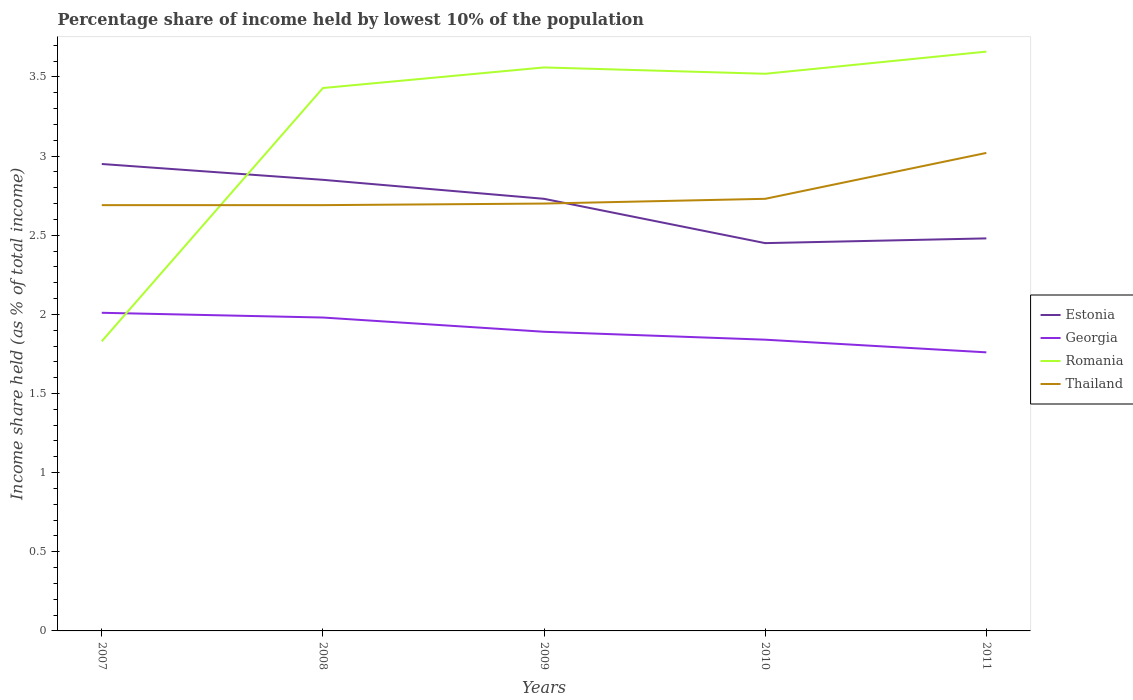Is the number of lines equal to the number of legend labels?
Provide a short and direct response. Yes. Across all years, what is the maximum percentage share of income held by lowest 10% of the population in Georgia?
Your answer should be compact. 1.76. What is the total percentage share of income held by lowest 10% of the population in Romania in the graph?
Offer a terse response. -0.1. What is the difference between the highest and the second highest percentage share of income held by lowest 10% of the population in Estonia?
Provide a short and direct response. 0.5. Is the percentage share of income held by lowest 10% of the population in Romania strictly greater than the percentage share of income held by lowest 10% of the population in Thailand over the years?
Give a very brief answer. No. How many years are there in the graph?
Provide a succinct answer. 5. What is the difference between two consecutive major ticks on the Y-axis?
Offer a very short reply. 0.5. Are the values on the major ticks of Y-axis written in scientific E-notation?
Offer a very short reply. No. Does the graph contain any zero values?
Offer a terse response. No. Does the graph contain grids?
Provide a succinct answer. No. Where does the legend appear in the graph?
Ensure brevity in your answer.  Center right. What is the title of the graph?
Keep it short and to the point. Percentage share of income held by lowest 10% of the population. What is the label or title of the Y-axis?
Provide a succinct answer. Income share held (as % of total income). What is the Income share held (as % of total income) of Estonia in 2007?
Offer a terse response. 2.95. What is the Income share held (as % of total income) in Georgia in 2007?
Keep it short and to the point. 2.01. What is the Income share held (as % of total income) of Romania in 2007?
Your answer should be compact. 1.83. What is the Income share held (as % of total income) of Thailand in 2007?
Offer a very short reply. 2.69. What is the Income share held (as % of total income) of Estonia in 2008?
Provide a short and direct response. 2.85. What is the Income share held (as % of total income) of Georgia in 2008?
Offer a very short reply. 1.98. What is the Income share held (as % of total income) in Romania in 2008?
Keep it short and to the point. 3.43. What is the Income share held (as % of total income) of Thailand in 2008?
Make the answer very short. 2.69. What is the Income share held (as % of total income) in Estonia in 2009?
Offer a very short reply. 2.73. What is the Income share held (as % of total income) in Georgia in 2009?
Ensure brevity in your answer.  1.89. What is the Income share held (as % of total income) of Romania in 2009?
Keep it short and to the point. 3.56. What is the Income share held (as % of total income) in Estonia in 2010?
Provide a short and direct response. 2.45. What is the Income share held (as % of total income) in Georgia in 2010?
Your answer should be compact. 1.84. What is the Income share held (as % of total income) of Romania in 2010?
Keep it short and to the point. 3.52. What is the Income share held (as % of total income) of Thailand in 2010?
Make the answer very short. 2.73. What is the Income share held (as % of total income) in Estonia in 2011?
Keep it short and to the point. 2.48. What is the Income share held (as % of total income) of Georgia in 2011?
Offer a terse response. 1.76. What is the Income share held (as % of total income) in Romania in 2011?
Provide a succinct answer. 3.66. What is the Income share held (as % of total income) in Thailand in 2011?
Provide a short and direct response. 3.02. Across all years, what is the maximum Income share held (as % of total income) in Estonia?
Your answer should be very brief. 2.95. Across all years, what is the maximum Income share held (as % of total income) of Georgia?
Ensure brevity in your answer.  2.01. Across all years, what is the maximum Income share held (as % of total income) in Romania?
Keep it short and to the point. 3.66. Across all years, what is the maximum Income share held (as % of total income) of Thailand?
Make the answer very short. 3.02. Across all years, what is the minimum Income share held (as % of total income) of Estonia?
Provide a succinct answer. 2.45. Across all years, what is the minimum Income share held (as % of total income) of Georgia?
Provide a succinct answer. 1.76. Across all years, what is the minimum Income share held (as % of total income) in Romania?
Provide a succinct answer. 1.83. Across all years, what is the minimum Income share held (as % of total income) of Thailand?
Ensure brevity in your answer.  2.69. What is the total Income share held (as % of total income) in Estonia in the graph?
Provide a short and direct response. 13.46. What is the total Income share held (as % of total income) of Georgia in the graph?
Provide a short and direct response. 9.48. What is the total Income share held (as % of total income) of Romania in the graph?
Give a very brief answer. 16. What is the total Income share held (as % of total income) in Thailand in the graph?
Ensure brevity in your answer.  13.83. What is the difference between the Income share held (as % of total income) of Estonia in 2007 and that in 2008?
Provide a short and direct response. 0.1. What is the difference between the Income share held (as % of total income) in Romania in 2007 and that in 2008?
Provide a succinct answer. -1.6. What is the difference between the Income share held (as % of total income) in Thailand in 2007 and that in 2008?
Offer a very short reply. 0. What is the difference between the Income share held (as % of total income) of Estonia in 2007 and that in 2009?
Give a very brief answer. 0.22. What is the difference between the Income share held (as % of total income) of Georgia in 2007 and that in 2009?
Ensure brevity in your answer.  0.12. What is the difference between the Income share held (as % of total income) in Romania in 2007 and that in 2009?
Offer a very short reply. -1.73. What is the difference between the Income share held (as % of total income) in Thailand in 2007 and that in 2009?
Keep it short and to the point. -0.01. What is the difference between the Income share held (as % of total income) of Estonia in 2007 and that in 2010?
Provide a short and direct response. 0.5. What is the difference between the Income share held (as % of total income) of Georgia in 2007 and that in 2010?
Keep it short and to the point. 0.17. What is the difference between the Income share held (as % of total income) of Romania in 2007 and that in 2010?
Your answer should be compact. -1.69. What is the difference between the Income share held (as % of total income) of Thailand in 2007 and that in 2010?
Provide a succinct answer. -0.04. What is the difference between the Income share held (as % of total income) of Estonia in 2007 and that in 2011?
Provide a succinct answer. 0.47. What is the difference between the Income share held (as % of total income) in Romania in 2007 and that in 2011?
Your answer should be compact. -1.83. What is the difference between the Income share held (as % of total income) in Thailand in 2007 and that in 2011?
Your response must be concise. -0.33. What is the difference between the Income share held (as % of total income) in Estonia in 2008 and that in 2009?
Your answer should be compact. 0.12. What is the difference between the Income share held (as % of total income) of Georgia in 2008 and that in 2009?
Your response must be concise. 0.09. What is the difference between the Income share held (as % of total income) in Romania in 2008 and that in 2009?
Offer a terse response. -0.13. What is the difference between the Income share held (as % of total income) of Thailand in 2008 and that in 2009?
Provide a short and direct response. -0.01. What is the difference between the Income share held (as % of total income) in Georgia in 2008 and that in 2010?
Your answer should be compact. 0.14. What is the difference between the Income share held (as % of total income) in Romania in 2008 and that in 2010?
Give a very brief answer. -0.09. What is the difference between the Income share held (as % of total income) in Thailand in 2008 and that in 2010?
Ensure brevity in your answer.  -0.04. What is the difference between the Income share held (as % of total income) of Estonia in 2008 and that in 2011?
Offer a terse response. 0.37. What is the difference between the Income share held (as % of total income) in Georgia in 2008 and that in 2011?
Offer a very short reply. 0.22. What is the difference between the Income share held (as % of total income) of Romania in 2008 and that in 2011?
Provide a succinct answer. -0.23. What is the difference between the Income share held (as % of total income) of Thailand in 2008 and that in 2011?
Give a very brief answer. -0.33. What is the difference between the Income share held (as % of total income) in Estonia in 2009 and that in 2010?
Provide a succinct answer. 0.28. What is the difference between the Income share held (as % of total income) in Romania in 2009 and that in 2010?
Ensure brevity in your answer.  0.04. What is the difference between the Income share held (as % of total income) in Thailand in 2009 and that in 2010?
Your answer should be very brief. -0.03. What is the difference between the Income share held (as % of total income) of Estonia in 2009 and that in 2011?
Offer a very short reply. 0.25. What is the difference between the Income share held (as % of total income) in Georgia in 2009 and that in 2011?
Ensure brevity in your answer.  0.13. What is the difference between the Income share held (as % of total income) in Romania in 2009 and that in 2011?
Provide a succinct answer. -0.1. What is the difference between the Income share held (as % of total income) in Thailand in 2009 and that in 2011?
Provide a succinct answer. -0.32. What is the difference between the Income share held (as % of total income) of Estonia in 2010 and that in 2011?
Provide a short and direct response. -0.03. What is the difference between the Income share held (as % of total income) in Romania in 2010 and that in 2011?
Ensure brevity in your answer.  -0.14. What is the difference between the Income share held (as % of total income) of Thailand in 2010 and that in 2011?
Offer a terse response. -0.29. What is the difference between the Income share held (as % of total income) of Estonia in 2007 and the Income share held (as % of total income) of Romania in 2008?
Make the answer very short. -0.48. What is the difference between the Income share held (as % of total income) of Estonia in 2007 and the Income share held (as % of total income) of Thailand in 2008?
Provide a succinct answer. 0.26. What is the difference between the Income share held (as % of total income) in Georgia in 2007 and the Income share held (as % of total income) in Romania in 2008?
Provide a succinct answer. -1.42. What is the difference between the Income share held (as % of total income) of Georgia in 2007 and the Income share held (as % of total income) of Thailand in 2008?
Give a very brief answer. -0.68. What is the difference between the Income share held (as % of total income) of Romania in 2007 and the Income share held (as % of total income) of Thailand in 2008?
Offer a very short reply. -0.86. What is the difference between the Income share held (as % of total income) in Estonia in 2007 and the Income share held (as % of total income) in Georgia in 2009?
Offer a very short reply. 1.06. What is the difference between the Income share held (as % of total income) in Estonia in 2007 and the Income share held (as % of total income) in Romania in 2009?
Keep it short and to the point. -0.61. What is the difference between the Income share held (as % of total income) in Georgia in 2007 and the Income share held (as % of total income) in Romania in 2009?
Your response must be concise. -1.55. What is the difference between the Income share held (as % of total income) of Georgia in 2007 and the Income share held (as % of total income) of Thailand in 2009?
Provide a succinct answer. -0.69. What is the difference between the Income share held (as % of total income) of Romania in 2007 and the Income share held (as % of total income) of Thailand in 2009?
Keep it short and to the point. -0.87. What is the difference between the Income share held (as % of total income) of Estonia in 2007 and the Income share held (as % of total income) of Georgia in 2010?
Your answer should be very brief. 1.11. What is the difference between the Income share held (as % of total income) in Estonia in 2007 and the Income share held (as % of total income) in Romania in 2010?
Your answer should be very brief. -0.57. What is the difference between the Income share held (as % of total income) in Estonia in 2007 and the Income share held (as % of total income) in Thailand in 2010?
Your response must be concise. 0.22. What is the difference between the Income share held (as % of total income) in Georgia in 2007 and the Income share held (as % of total income) in Romania in 2010?
Ensure brevity in your answer.  -1.51. What is the difference between the Income share held (as % of total income) of Georgia in 2007 and the Income share held (as % of total income) of Thailand in 2010?
Give a very brief answer. -0.72. What is the difference between the Income share held (as % of total income) in Romania in 2007 and the Income share held (as % of total income) in Thailand in 2010?
Your response must be concise. -0.9. What is the difference between the Income share held (as % of total income) in Estonia in 2007 and the Income share held (as % of total income) in Georgia in 2011?
Make the answer very short. 1.19. What is the difference between the Income share held (as % of total income) in Estonia in 2007 and the Income share held (as % of total income) in Romania in 2011?
Give a very brief answer. -0.71. What is the difference between the Income share held (as % of total income) in Estonia in 2007 and the Income share held (as % of total income) in Thailand in 2011?
Offer a very short reply. -0.07. What is the difference between the Income share held (as % of total income) in Georgia in 2007 and the Income share held (as % of total income) in Romania in 2011?
Make the answer very short. -1.65. What is the difference between the Income share held (as % of total income) of Georgia in 2007 and the Income share held (as % of total income) of Thailand in 2011?
Your answer should be compact. -1.01. What is the difference between the Income share held (as % of total income) in Romania in 2007 and the Income share held (as % of total income) in Thailand in 2011?
Make the answer very short. -1.19. What is the difference between the Income share held (as % of total income) of Estonia in 2008 and the Income share held (as % of total income) of Romania in 2009?
Your answer should be very brief. -0.71. What is the difference between the Income share held (as % of total income) of Georgia in 2008 and the Income share held (as % of total income) of Romania in 2009?
Provide a short and direct response. -1.58. What is the difference between the Income share held (as % of total income) of Georgia in 2008 and the Income share held (as % of total income) of Thailand in 2009?
Your response must be concise. -0.72. What is the difference between the Income share held (as % of total income) in Romania in 2008 and the Income share held (as % of total income) in Thailand in 2009?
Your response must be concise. 0.73. What is the difference between the Income share held (as % of total income) of Estonia in 2008 and the Income share held (as % of total income) of Georgia in 2010?
Offer a very short reply. 1.01. What is the difference between the Income share held (as % of total income) in Estonia in 2008 and the Income share held (as % of total income) in Romania in 2010?
Your response must be concise. -0.67. What is the difference between the Income share held (as % of total income) of Estonia in 2008 and the Income share held (as % of total income) of Thailand in 2010?
Ensure brevity in your answer.  0.12. What is the difference between the Income share held (as % of total income) in Georgia in 2008 and the Income share held (as % of total income) in Romania in 2010?
Make the answer very short. -1.54. What is the difference between the Income share held (as % of total income) of Georgia in 2008 and the Income share held (as % of total income) of Thailand in 2010?
Offer a terse response. -0.75. What is the difference between the Income share held (as % of total income) in Romania in 2008 and the Income share held (as % of total income) in Thailand in 2010?
Your answer should be compact. 0.7. What is the difference between the Income share held (as % of total income) of Estonia in 2008 and the Income share held (as % of total income) of Georgia in 2011?
Ensure brevity in your answer.  1.09. What is the difference between the Income share held (as % of total income) in Estonia in 2008 and the Income share held (as % of total income) in Romania in 2011?
Give a very brief answer. -0.81. What is the difference between the Income share held (as % of total income) in Estonia in 2008 and the Income share held (as % of total income) in Thailand in 2011?
Offer a terse response. -0.17. What is the difference between the Income share held (as % of total income) of Georgia in 2008 and the Income share held (as % of total income) of Romania in 2011?
Your answer should be compact. -1.68. What is the difference between the Income share held (as % of total income) of Georgia in 2008 and the Income share held (as % of total income) of Thailand in 2011?
Your response must be concise. -1.04. What is the difference between the Income share held (as % of total income) in Romania in 2008 and the Income share held (as % of total income) in Thailand in 2011?
Your response must be concise. 0.41. What is the difference between the Income share held (as % of total income) of Estonia in 2009 and the Income share held (as % of total income) of Georgia in 2010?
Give a very brief answer. 0.89. What is the difference between the Income share held (as % of total income) of Estonia in 2009 and the Income share held (as % of total income) of Romania in 2010?
Give a very brief answer. -0.79. What is the difference between the Income share held (as % of total income) in Georgia in 2009 and the Income share held (as % of total income) in Romania in 2010?
Your response must be concise. -1.63. What is the difference between the Income share held (as % of total income) of Georgia in 2009 and the Income share held (as % of total income) of Thailand in 2010?
Your answer should be compact. -0.84. What is the difference between the Income share held (as % of total income) of Romania in 2009 and the Income share held (as % of total income) of Thailand in 2010?
Provide a short and direct response. 0.83. What is the difference between the Income share held (as % of total income) in Estonia in 2009 and the Income share held (as % of total income) in Georgia in 2011?
Your answer should be compact. 0.97. What is the difference between the Income share held (as % of total income) in Estonia in 2009 and the Income share held (as % of total income) in Romania in 2011?
Provide a short and direct response. -0.93. What is the difference between the Income share held (as % of total income) in Estonia in 2009 and the Income share held (as % of total income) in Thailand in 2011?
Provide a short and direct response. -0.29. What is the difference between the Income share held (as % of total income) in Georgia in 2009 and the Income share held (as % of total income) in Romania in 2011?
Provide a succinct answer. -1.77. What is the difference between the Income share held (as % of total income) in Georgia in 2009 and the Income share held (as % of total income) in Thailand in 2011?
Provide a short and direct response. -1.13. What is the difference between the Income share held (as % of total income) of Romania in 2009 and the Income share held (as % of total income) of Thailand in 2011?
Your answer should be very brief. 0.54. What is the difference between the Income share held (as % of total income) in Estonia in 2010 and the Income share held (as % of total income) in Georgia in 2011?
Provide a succinct answer. 0.69. What is the difference between the Income share held (as % of total income) of Estonia in 2010 and the Income share held (as % of total income) of Romania in 2011?
Provide a short and direct response. -1.21. What is the difference between the Income share held (as % of total income) in Estonia in 2010 and the Income share held (as % of total income) in Thailand in 2011?
Give a very brief answer. -0.57. What is the difference between the Income share held (as % of total income) in Georgia in 2010 and the Income share held (as % of total income) in Romania in 2011?
Provide a short and direct response. -1.82. What is the difference between the Income share held (as % of total income) of Georgia in 2010 and the Income share held (as % of total income) of Thailand in 2011?
Provide a succinct answer. -1.18. What is the average Income share held (as % of total income) of Estonia per year?
Offer a terse response. 2.69. What is the average Income share held (as % of total income) of Georgia per year?
Offer a terse response. 1.9. What is the average Income share held (as % of total income) of Romania per year?
Your response must be concise. 3.2. What is the average Income share held (as % of total income) in Thailand per year?
Offer a terse response. 2.77. In the year 2007, what is the difference between the Income share held (as % of total income) of Estonia and Income share held (as % of total income) of Romania?
Ensure brevity in your answer.  1.12. In the year 2007, what is the difference between the Income share held (as % of total income) of Estonia and Income share held (as % of total income) of Thailand?
Offer a very short reply. 0.26. In the year 2007, what is the difference between the Income share held (as % of total income) in Georgia and Income share held (as % of total income) in Romania?
Offer a very short reply. 0.18. In the year 2007, what is the difference between the Income share held (as % of total income) in Georgia and Income share held (as % of total income) in Thailand?
Provide a short and direct response. -0.68. In the year 2007, what is the difference between the Income share held (as % of total income) of Romania and Income share held (as % of total income) of Thailand?
Offer a terse response. -0.86. In the year 2008, what is the difference between the Income share held (as % of total income) of Estonia and Income share held (as % of total income) of Georgia?
Make the answer very short. 0.87. In the year 2008, what is the difference between the Income share held (as % of total income) of Estonia and Income share held (as % of total income) of Romania?
Your response must be concise. -0.58. In the year 2008, what is the difference between the Income share held (as % of total income) in Estonia and Income share held (as % of total income) in Thailand?
Make the answer very short. 0.16. In the year 2008, what is the difference between the Income share held (as % of total income) in Georgia and Income share held (as % of total income) in Romania?
Your response must be concise. -1.45. In the year 2008, what is the difference between the Income share held (as % of total income) of Georgia and Income share held (as % of total income) of Thailand?
Provide a succinct answer. -0.71. In the year 2008, what is the difference between the Income share held (as % of total income) in Romania and Income share held (as % of total income) in Thailand?
Your answer should be compact. 0.74. In the year 2009, what is the difference between the Income share held (as % of total income) of Estonia and Income share held (as % of total income) of Georgia?
Give a very brief answer. 0.84. In the year 2009, what is the difference between the Income share held (as % of total income) of Estonia and Income share held (as % of total income) of Romania?
Offer a terse response. -0.83. In the year 2009, what is the difference between the Income share held (as % of total income) in Estonia and Income share held (as % of total income) in Thailand?
Make the answer very short. 0.03. In the year 2009, what is the difference between the Income share held (as % of total income) of Georgia and Income share held (as % of total income) of Romania?
Offer a terse response. -1.67. In the year 2009, what is the difference between the Income share held (as % of total income) in Georgia and Income share held (as % of total income) in Thailand?
Keep it short and to the point. -0.81. In the year 2009, what is the difference between the Income share held (as % of total income) of Romania and Income share held (as % of total income) of Thailand?
Ensure brevity in your answer.  0.86. In the year 2010, what is the difference between the Income share held (as % of total income) of Estonia and Income share held (as % of total income) of Georgia?
Your answer should be compact. 0.61. In the year 2010, what is the difference between the Income share held (as % of total income) in Estonia and Income share held (as % of total income) in Romania?
Provide a succinct answer. -1.07. In the year 2010, what is the difference between the Income share held (as % of total income) in Estonia and Income share held (as % of total income) in Thailand?
Offer a very short reply. -0.28. In the year 2010, what is the difference between the Income share held (as % of total income) of Georgia and Income share held (as % of total income) of Romania?
Offer a very short reply. -1.68. In the year 2010, what is the difference between the Income share held (as % of total income) in Georgia and Income share held (as % of total income) in Thailand?
Offer a very short reply. -0.89. In the year 2010, what is the difference between the Income share held (as % of total income) in Romania and Income share held (as % of total income) in Thailand?
Make the answer very short. 0.79. In the year 2011, what is the difference between the Income share held (as % of total income) in Estonia and Income share held (as % of total income) in Georgia?
Make the answer very short. 0.72. In the year 2011, what is the difference between the Income share held (as % of total income) in Estonia and Income share held (as % of total income) in Romania?
Provide a short and direct response. -1.18. In the year 2011, what is the difference between the Income share held (as % of total income) of Estonia and Income share held (as % of total income) of Thailand?
Make the answer very short. -0.54. In the year 2011, what is the difference between the Income share held (as % of total income) of Georgia and Income share held (as % of total income) of Thailand?
Offer a very short reply. -1.26. In the year 2011, what is the difference between the Income share held (as % of total income) in Romania and Income share held (as % of total income) in Thailand?
Keep it short and to the point. 0.64. What is the ratio of the Income share held (as % of total income) of Estonia in 2007 to that in 2008?
Offer a terse response. 1.04. What is the ratio of the Income share held (as % of total income) of Georgia in 2007 to that in 2008?
Offer a terse response. 1.02. What is the ratio of the Income share held (as % of total income) of Romania in 2007 to that in 2008?
Give a very brief answer. 0.53. What is the ratio of the Income share held (as % of total income) of Thailand in 2007 to that in 2008?
Your response must be concise. 1. What is the ratio of the Income share held (as % of total income) of Estonia in 2007 to that in 2009?
Your response must be concise. 1.08. What is the ratio of the Income share held (as % of total income) in Georgia in 2007 to that in 2009?
Offer a terse response. 1.06. What is the ratio of the Income share held (as % of total income) of Romania in 2007 to that in 2009?
Ensure brevity in your answer.  0.51. What is the ratio of the Income share held (as % of total income) in Estonia in 2007 to that in 2010?
Your response must be concise. 1.2. What is the ratio of the Income share held (as % of total income) in Georgia in 2007 to that in 2010?
Provide a succinct answer. 1.09. What is the ratio of the Income share held (as % of total income) of Romania in 2007 to that in 2010?
Provide a succinct answer. 0.52. What is the ratio of the Income share held (as % of total income) of Thailand in 2007 to that in 2010?
Your response must be concise. 0.99. What is the ratio of the Income share held (as % of total income) in Estonia in 2007 to that in 2011?
Make the answer very short. 1.19. What is the ratio of the Income share held (as % of total income) in Georgia in 2007 to that in 2011?
Your answer should be compact. 1.14. What is the ratio of the Income share held (as % of total income) of Thailand in 2007 to that in 2011?
Make the answer very short. 0.89. What is the ratio of the Income share held (as % of total income) of Estonia in 2008 to that in 2009?
Offer a very short reply. 1.04. What is the ratio of the Income share held (as % of total income) of Georgia in 2008 to that in 2009?
Provide a short and direct response. 1.05. What is the ratio of the Income share held (as % of total income) of Romania in 2008 to that in 2009?
Your response must be concise. 0.96. What is the ratio of the Income share held (as % of total income) of Thailand in 2008 to that in 2009?
Keep it short and to the point. 1. What is the ratio of the Income share held (as % of total income) in Estonia in 2008 to that in 2010?
Make the answer very short. 1.16. What is the ratio of the Income share held (as % of total income) of Georgia in 2008 to that in 2010?
Your answer should be compact. 1.08. What is the ratio of the Income share held (as % of total income) of Romania in 2008 to that in 2010?
Offer a terse response. 0.97. What is the ratio of the Income share held (as % of total income) in Estonia in 2008 to that in 2011?
Keep it short and to the point. 1.15. What is the ratio of the Income share held (as % of total income) in Romania in 2008 to that in 2011?
Give a very brief answer. 0.94. What is the ratio of the Income share held (as % of total income) in Thailand in 2008 to that in 2011?
Provide a short and direct response. 0.89. What is the ratio of the Income share held (as % of total income) of Estonia in 2009 to that in 2010?
Ensure brevity in your answer.  1.11. What is the ratio of the Income share held (as % of total income) of Georgia in 2009 to that in 2010?
Offer a terse response. 1.03. What is the ratio of the Income share held (as % of total income) of Romania in 2009 to that in 2010?
Your answer should be very brief. 1.01. What is the ratio of the Income share held (as % of total income) of Estonia in 2009 to that in 2011?
Your answer should be compact. 1.1. What is the ratio of the Income share held (as % of total income) in Georgia in 2009 to that in 2011?
Provide a succinct answer. 1.07. What is the ratio of the Income share held (as % of total income) of Romania in 2009 to that in 2011?
Your answer should be compact. 0.97. What is the ratio of the Income share held (as % of total income) in Thailand in 2009 to that in 2011?
Provide a short and direct response. 0.89. What is the ratio of the Income share held (as % of total income) of Estonia in 2010 to that in 2011?
Your response must be concise. 0.99. What is the ratio of the Income share held (as % of total income) in Georgia in 2010 to that in 2011?
Your answer should be compact. 1.05. What is the ratio of the Income share held (as % of total income) of Romania in 2010 to that in 2011?
Offer a terse response. 0.96. What is the ratio of the Income share held (as % of total income) in Thailand in 2010 to that in 2011?
Ensure brevity in your answer.  0.9. What is the difference between the highest and the second highest Income share held (as % of total income) in Estonia?
Provide a succinct answer. 0.1. What is the difference between the highest and the second highest Income share held (as % of total income) in Georgia?
Keep it short and to the point. 0.03. What is the difference between the highest and the second highest Income share held (as % of total income) in Thailand?
Make the answer very short. 0.29. What is the difference between the highest and the lowest Income share held (as % of total income) of Romania?
Your answer should be very brief. 1.83. What is the difference between the highest and the lowest Income share held (as % of total income) in Thailand?
Ensure brevity in your answer.  0.33. 